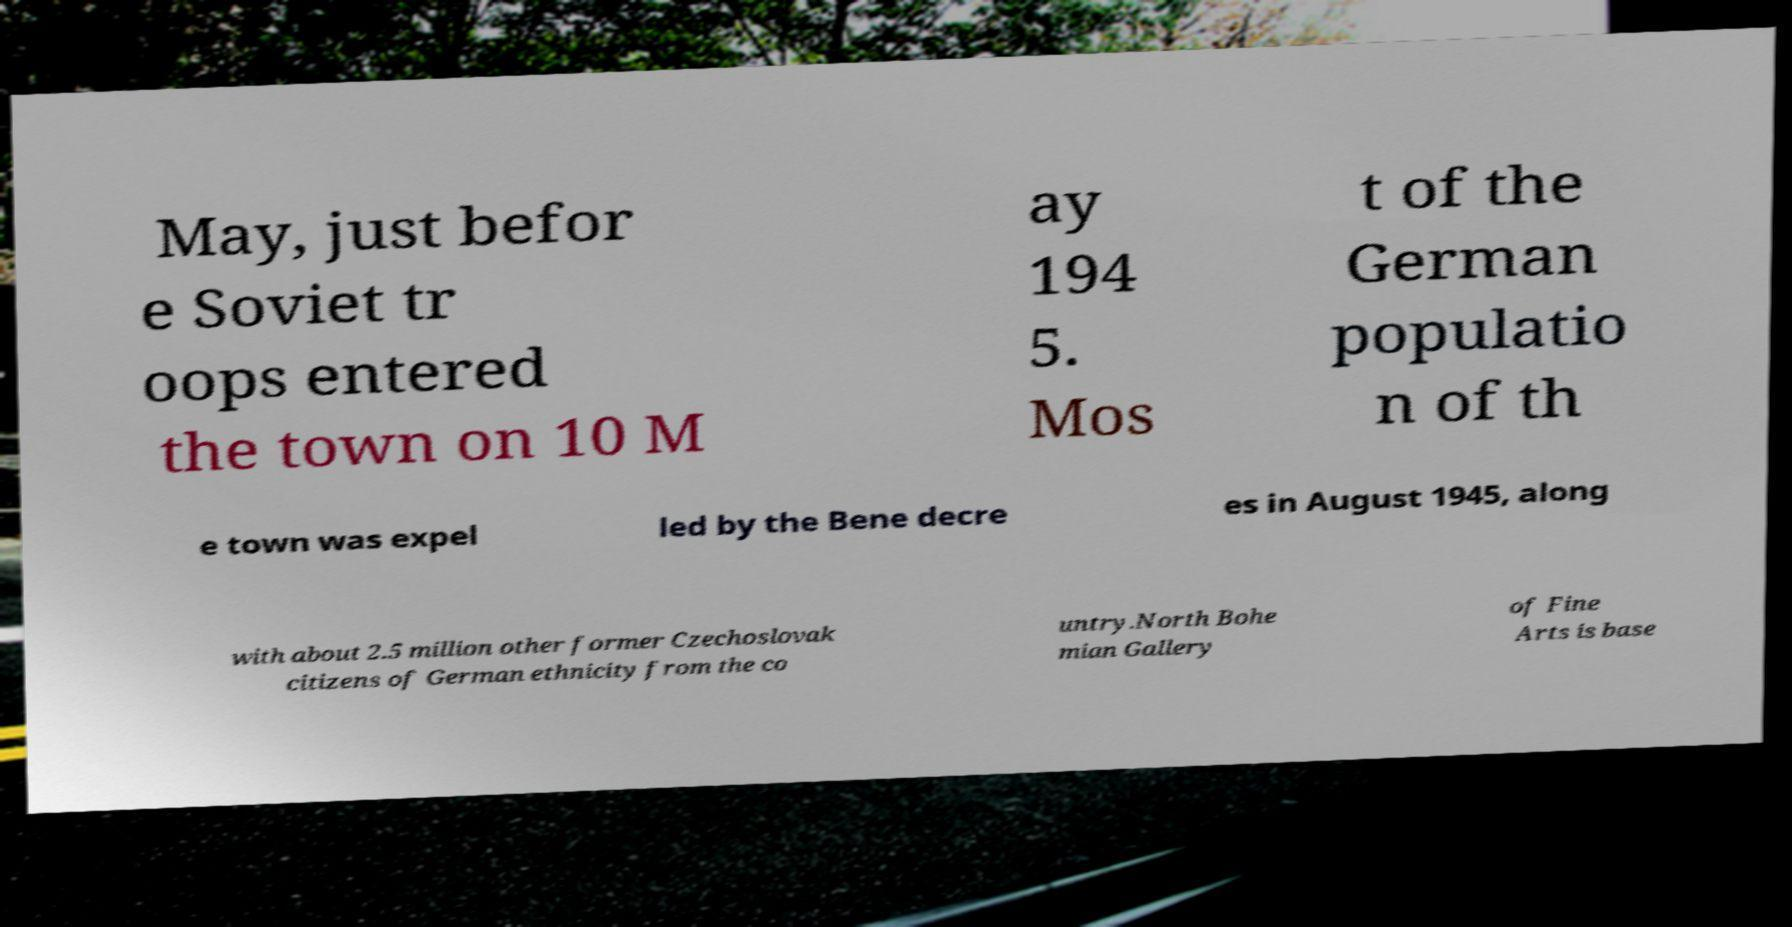I need the written content from this picture converted into text. Can you do that? May, just befor e Soviet tr oops entered the town on 10 M ay 194 5. Mos t of the German populatio n of th e town was expel led by the Bene decre es in August 1945, along with about 2.5 million other former Czechoslovak citizens of German ethnicity from the co untry.North Bohe mian Gallery of Fine Arts is base 